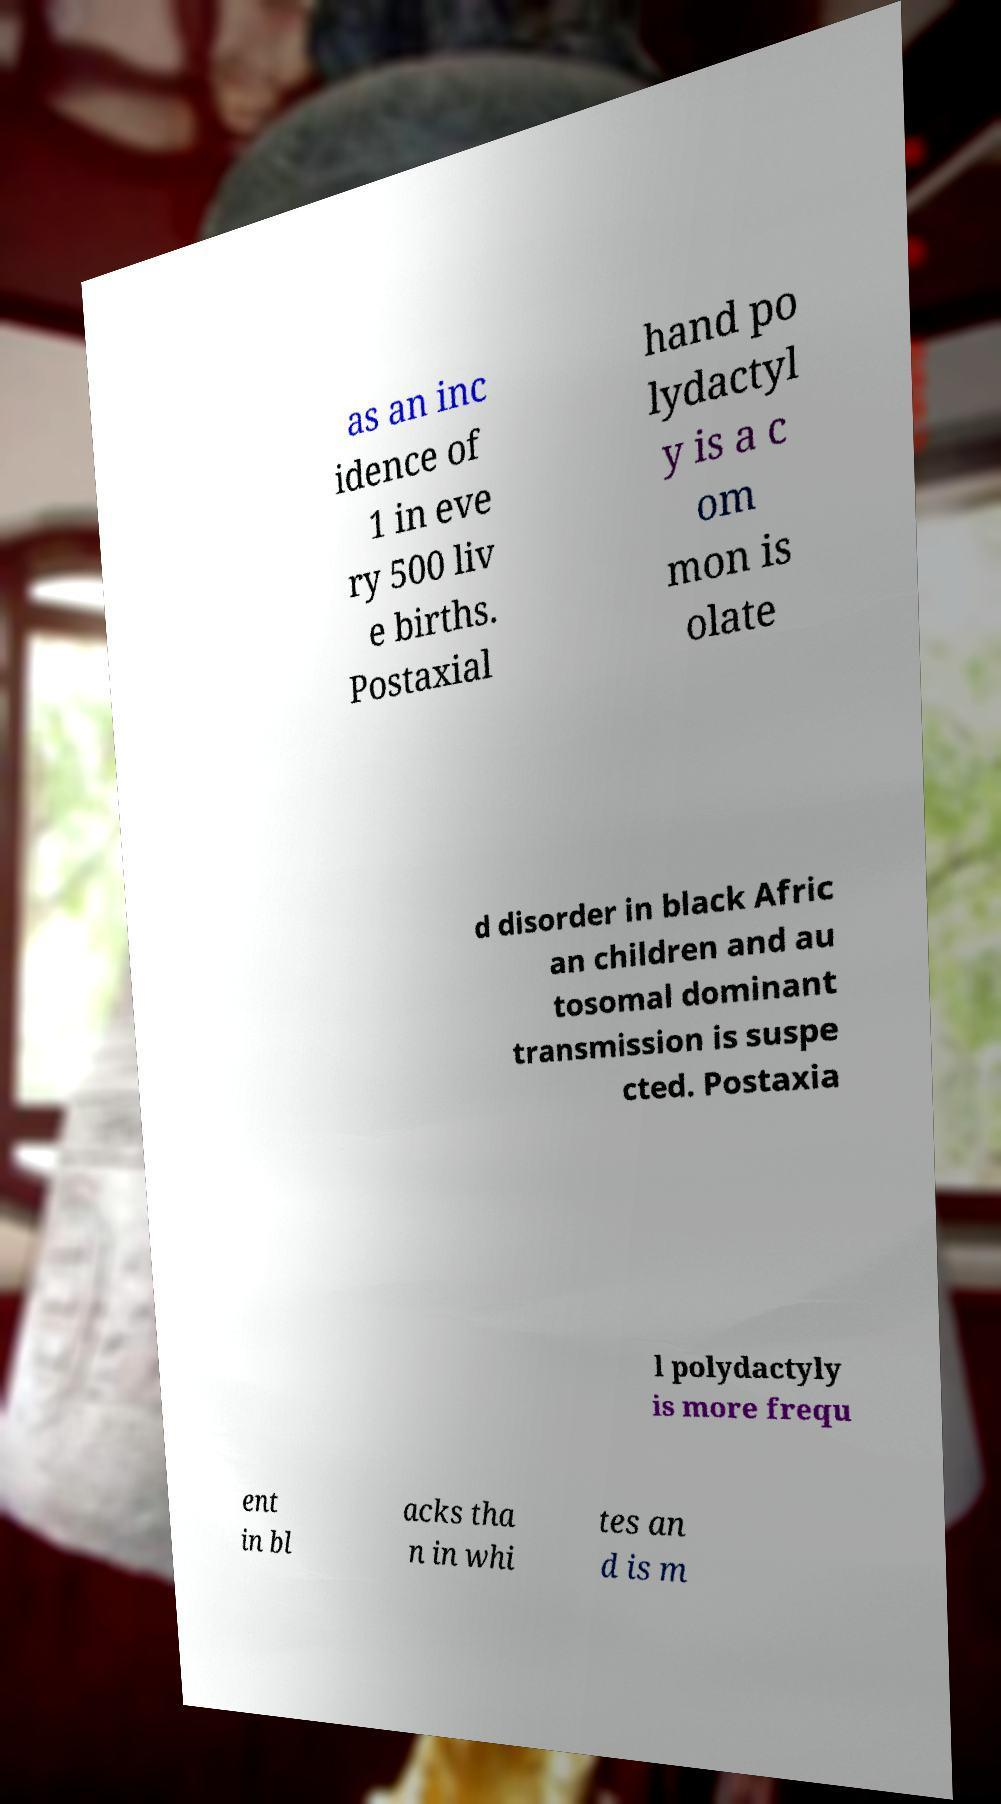There's text embedded in this image that I need extracted. Can you transcribe it verbatim? as an inc idence of 1 in eve ry 500 liv e births. Postaxial hand po lydactyl y is a c om mon is olate d disorder in black Afric an children and au tosomal dominant transmission is suspe cted. Postaxia l polydactyly is more frequ ent in bl acks tha n in whi tes an d is m 